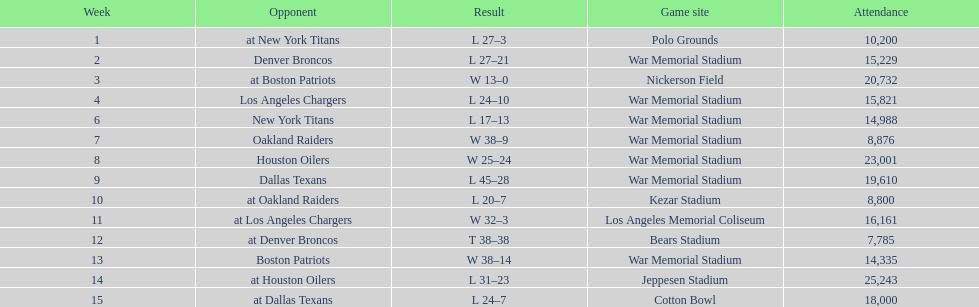Parse the table in full. {'header': ['Week', 'Opponent', 'Result', 'Game site', 'Attendance'], 'rows': [['1', 'at New York Titans', 'L 27–3', 'Polo Grounds', '10,200'], ['2', 'Denver Broncos', 'L 27–21', 'War Memorial Stadium', '15,229'], ['3', 'at Boston Patriots', 'W 13–0', 'Nickerson Field', '20,732'], ['4', 'Los Angeles Chargers', 'L 24–10', 'War Memorial Stadium', '15,821'], ['6', 'New York Titans', 'L 17–13', 'War Memorial Stadium', '14,988'], ['7', 'Oakland Raiders', 'W 38–9', 'War Memorial Stadium', '8,876'], ['8', 'Houston Oilers', 'W 25–24', 'War Memorial Stadium', '23,001'], ['9', 'Dallas Texans', 'L 45–28', 'War Memorial Stadium', '19,610'], ['10', 'at Oakland Raiders', 'L 20–7', 'Kezar Stadium', '8,800'], ['11', 'at Los Angeles Chargers', 'W 32–3', 'Los Angeles Memorial Coliseum', '16,161'], ['12', 'at Denver Broncos', 'T 38–38', 'Bears Stadium', '7,785'], ['13', 'Boston Patriots', 'W 38–14', 'War Memorial Stadium', '14,335'], ['14', 'at Houston Oilers', 'L 31–23', 'Jeppesen Stadium', '25,243'], ['15', 'at Dallas Texans', 'L 24–7', 'Cotton Bowl', '18,000']]} What was the largest point margin in a single contest? 29. 